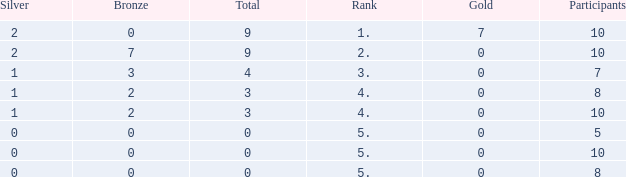What is listed as the highest Rank that has a Gold that's larger than 0, and Participants that's smaller than 10? None. 